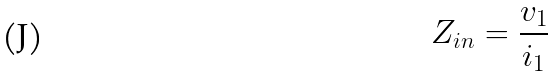<formula> <loc_0><loc_0><loc_500><loc_500>Z _ { i n } = \frac { v _ { 1 } } { i _ { 1 } }</formula> 